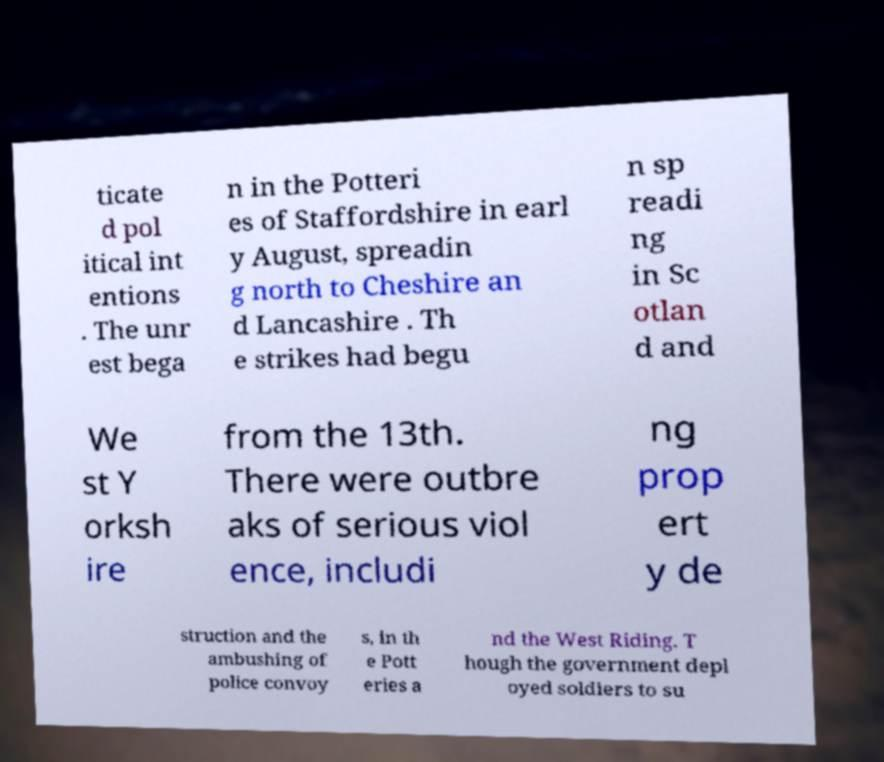Could you extract and type out the text from this image? ticate d pol itical int entions . The unr est bega n in the Potteri es of Staffordshire in earl y August, spreadin g north to Cheshire an d Lancashire . Th e strikes had begu n sp readi ng in Sc otlan d and We st Y orksh ire from the 13th. There were outbre aks of serious viol ence, includi ng prop ert y de struction and the ambushing of police convoy s, in th e Pott eries a nd the West Riding. T hough the government depl oyed soldiers to su 